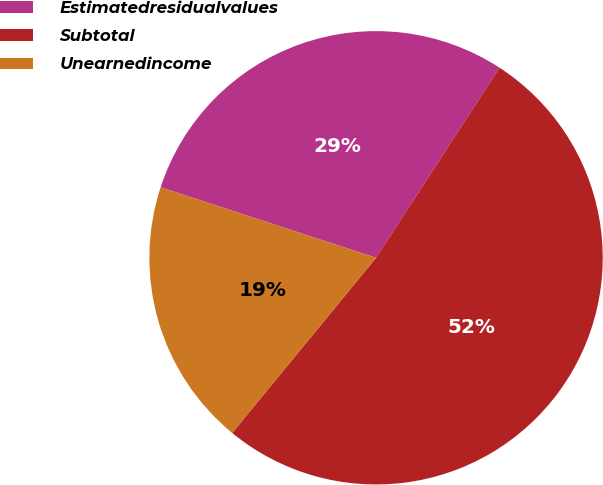Convert chart to OTSL. <chart><loc_0><loc_0><loc_500><loc_500><pie_chart><fcel>Estimatedresidualvalues<fcel>Subtotal<fcel>Unearnedincome<nl><fcel>29.14%<fcel>51.77%<fcel>19.09%<nl></chart> 